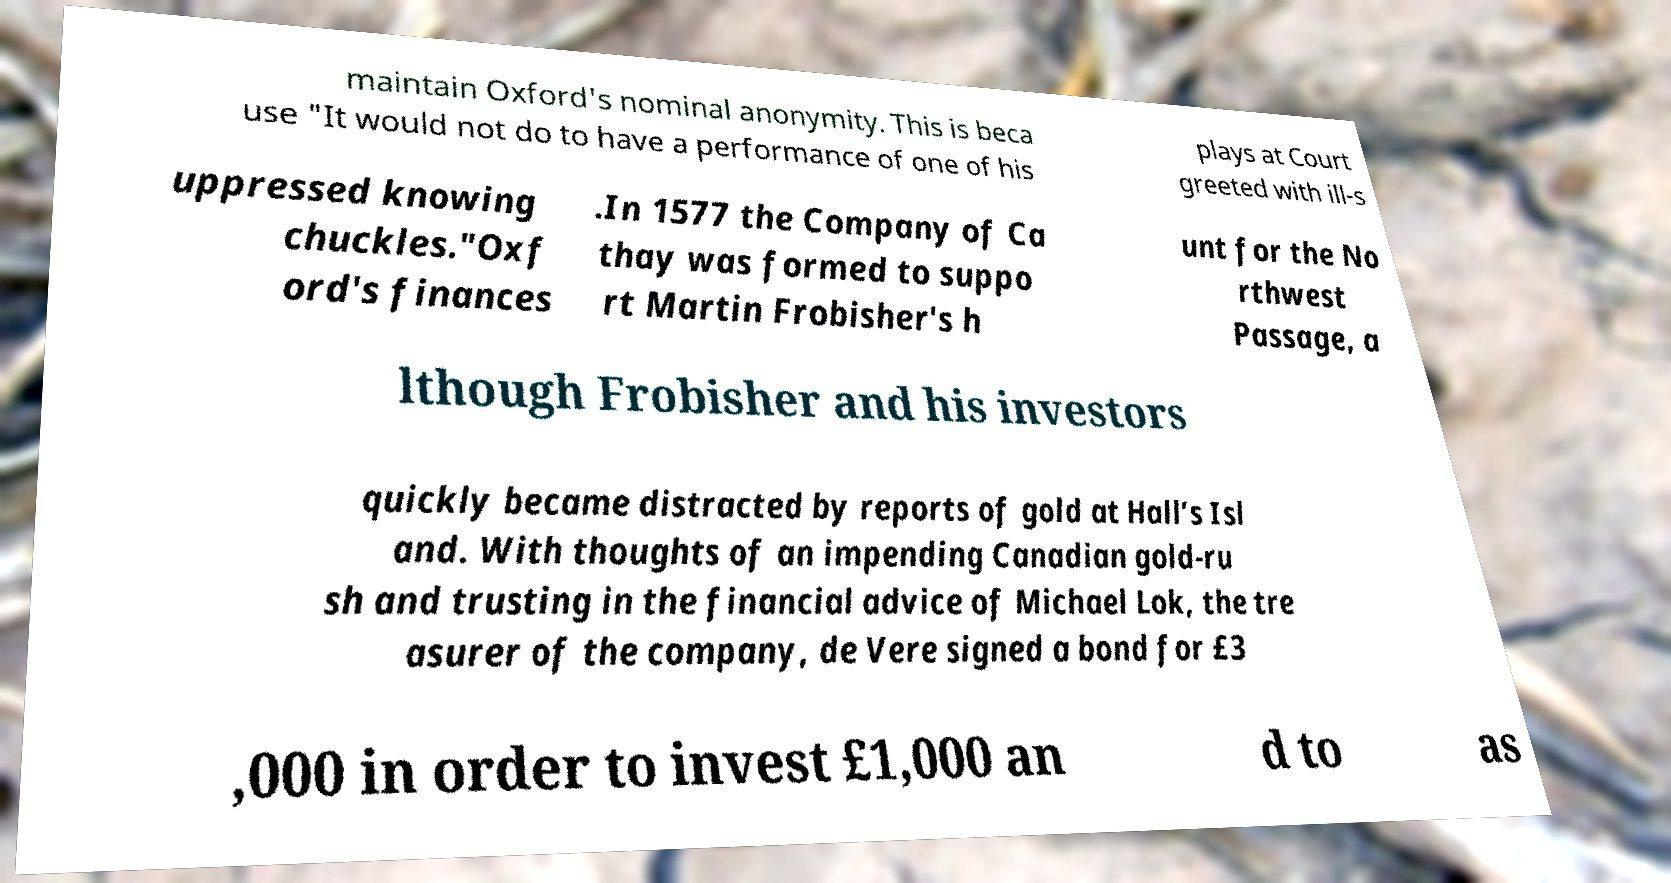Can you read and provide the text displayed in the image?This photo seems to have some interesting text. Can you extract and type it out for me? maintain Oxford's nominal anonymity. This is beca use "It would not do to have a performance of one of his plays at Court greeted with ill-s uppressed knowing chuckles."Oxf ord's finances .In 1577 the Company of Ca thay was formed to suppo rt Martin Frobisher's h unt for the No rthwest Passage, a lthough Frobisher and his investors quickly became distracted by reports of gold at Hall’s Isl and. With thoughts of an impending Canadian gold-ru sh and trusting in the financial advice of Michael Lok, the tre asurer of the company, de Vere signed a bond for £3 ,000 in order to invest £1,000 an d to as 